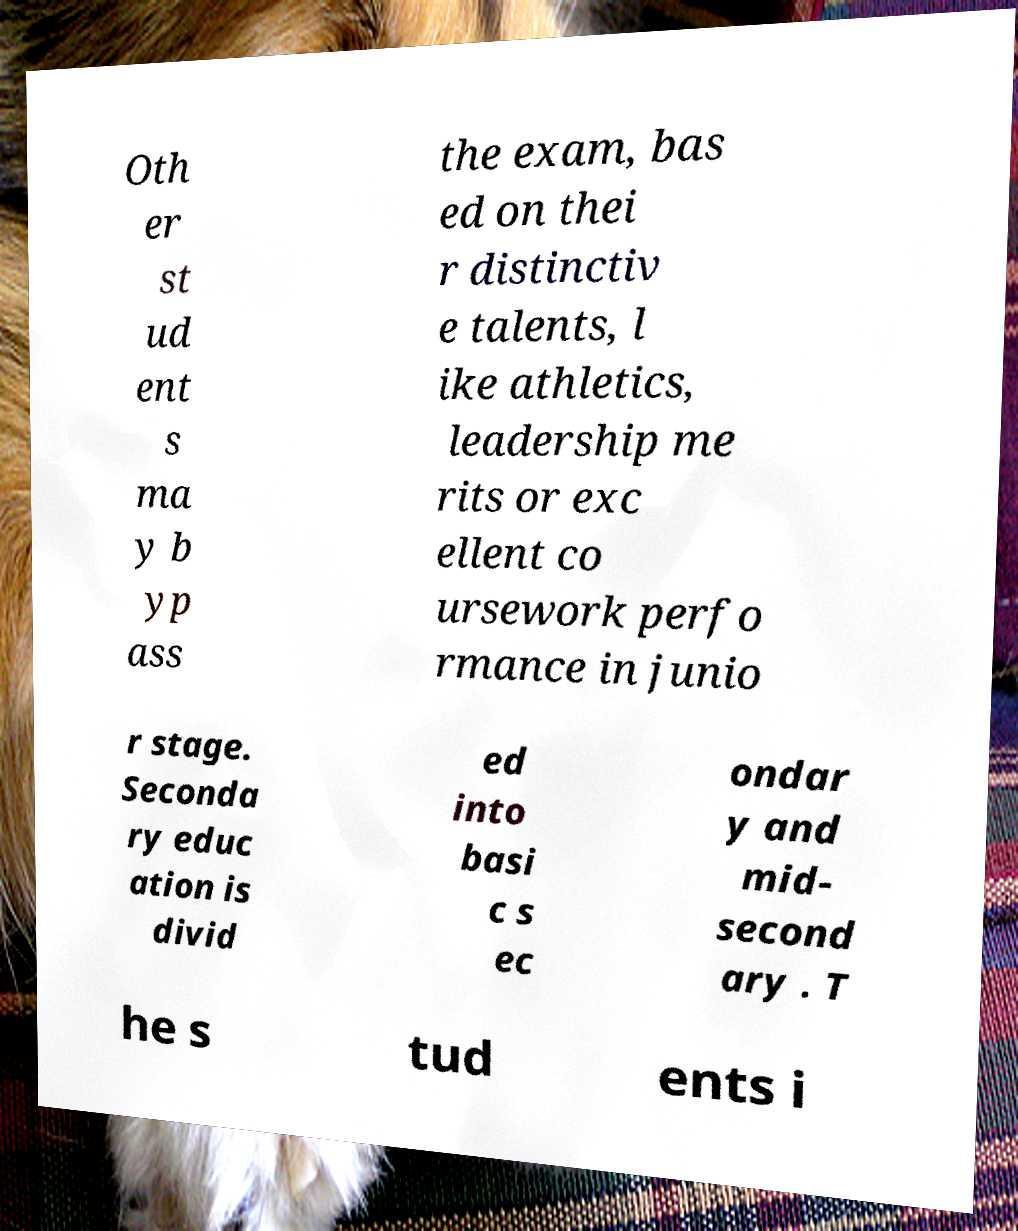Could you assist in decoding the text presented in this image and type it out clearly? Oth er st ud ent s ma y b yp ass the exam, bas ed on thei r distinctiv e talents, l ike athletics, leadership me rits or exc ellent co ursework perfo rmance in junio r stage. Seconda ry educ ation is divid ed into basi c s ec ondar y and mid- second ary . T he s tud ents i 